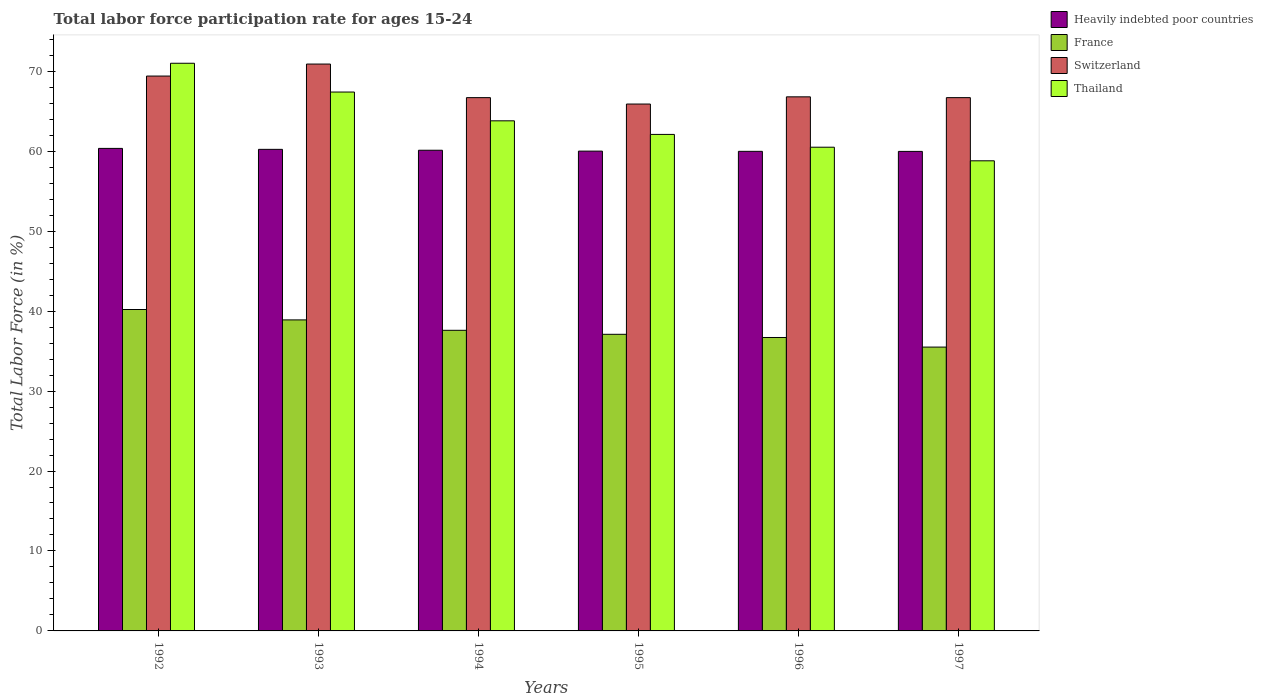How many different coloured bars are there?
Offer a very short reply. 4. How many groups of bars are there?
Offer a very short reply. 6. Are the number of bars per tick equal to the number of legend labels?
Make the answer very short. Yes. Are the number of bars on each tick of the X-axis equal?
Your answer should be compact. Yes. How many bars are there on the 6th tick from the right?
Give a very brief answer. 4. In how many cases, is the number of bars for a given year not equal to the number of legend labels?
Provide a short and direct response. 0. What is the labor force participation rate in Switzerland in 1992?
Your answer should be very brief. 69.4. Across all years, what is the maximum labor force participation rate in France?
Your response must be concise. 40.2. Across all years, what is the minimum labor force participation rate in Thailand?
Your response must be concise. 58.8. In which year was the labor force participation rate in France maximum?
Make the answer very short. 1992. What is the total labor force participation rate in Switzerland in the graph?
Keep it short and to the point. 406.4. What is the difference between the labor force participation rate in Switzerland in 1996 and that in 1997?
Your answer should be very brief. 0.1. What is the difference between the labor force participation rate in Switzerland in 1997 and the labor force participation rate in Heavily indebted poor countries in 1996?
Your answer should be very brief. 6.72. What is the average labor force participation rate in Thailand per year?
Keep it short and to the point. 63.93. In the year 1993, what is the difference between the labor force participation rate in Switzerland and labor force participation rate in France?
Your response must be concise. 32. What is the ratio of the labor force participation rate in Thailand in 1993 to that in 1995?
Offer a very short reply. 1.09. Is the difference between the labor force participation rate in Switzerland in 1992 and 1993 greater than the difference between the labor force participation rate in France in 1992 and 1993?
Give a very brief answer. No. What is the difference between the highest and the second highest labor force participation rate in Switzerland?
Make the answer very short. 1.5. What is the difference between the highest and the lowest labor force participation rate in France?
Give a very brief answer. 4.7. In how many years, is the labor force participation rate in Switzerland greater than the average labor force participation rate in Switzerland taken over all years?
Keep it short and to the point. 2. Is it the case that in every year, the sum of the labor force participation rate in Switzerland and labor force participation rate in Heavily indebted poor countries is greater than the sum of labor force participation rate in France and labor force participation rate in Thailand?
Your response must be concise. Yes. What does the 2nd bar from the left in 1992 represents?
Make the answer very short. France. What does the 4th bar from the right in 1995 represents?
Keep it short and to the point. Heavily indebted poor countries. Is it the case that in every year, the sum of the labor force participation rate in France and labor force participation rate in Switzerland is greater than the labor force participation rate in Heavily indebted poor countries?
Offer a terse response. Yes. How many years are there in the graph?
Keep it short and to the point. 6. Does the graph contain grids?
Offer a terse response. No. How many legend labels are there?
Offer a terse response. 4. How are the legend labels stacked?
Your answer should be very brief. Vertical. What is the title of the graph?
Provide a succinct answer. Total labor force participation rate for ages 15-24. What is the label or title of the X-axis?
Provide a short and direct response. Years. What is the Total Labor Force (in %) of Heavily indebted poor countries in 1992?
Offer a terse response. 60.35. What is the Total Labor Force (in %) of France in 1992?
Offer a terse response. 40.2. What is the Total Labor Force (in %) in Switzerland in 1992?
Provide a succinct answer. 69.4. What is the Total Labor Force (in %) of Thailand in 1992?
Your response must be concise. 71. What is the Total Labor Force (in %) of Heavily indebted poor countries in 1993?
Provide a short and direct response. 60.23. What is the Total Labor Force (in %) in France in 1993?
Your answer should be very brief. 38.9. What is the Total Labor Force (in %) of Switzerland in 1993?
Offer a terse response. 70.9. What is the Total Labor Force (in %) of Thailand in 1993?
Provide a short and direct response. 67.4. What is the Total Labor Force (in %) of Heavily indebted poor countries in 1994?
Keep it short and to the point. 60.12. What is the Total Labor Force (in %) of France in 1994?
Keep it short and to the point. 37.6. What is the Total Labor Force (in %) in Switzerland in 1994?
Provide a succinct answer. 66.7. What is the Total Labor Force (in %) in Thailand in 1994?
Your response must be concise. 63.8. What is the Total Labor Force (in %) of Heavily indebted poor countries in 1995?
Offer a very short reply. 60.01. What is the Total Labor Force (in %) in France in 1995?
Offer a very short reply. 37.1. What is the Total Labor Force (in %) in Switzerland in 1995?
Your answer should be compact. 65.9. What is the Total Labor Force (in %) in Thailand in 1995?
Make the answer very short. 62.1. What is the Total Labor Force (in %) in Heavily indebted poor countries in 1996?
Give a very brief answer. 59.98. What is the Total Labor Force (in %) in France in 1996?
Offer a terse response. 36.7. What is the Total Labor Force (in %) of Switzerland in 1996?
Your answer should be very brief. 66.8. What is the Total Labor Force (in %) of Thailand in 1996?
Provide a succinct answer. 60.5. What is the Total Labor Force (in %) of Heavily indebted poor countries in 1997?
Offer a very short reply. 59.98. What is the Total Labor Force (in %) of France in 1997?
Keep it short and to the point. 35.5. What is the Total Labor Force (in %) in Switzerland in 1997?
Provide a succinct answer. 66.7. What is the Total Labor Force (in %) of Thailand in 1997?
Make the answer very short. 58.8. Across all years, what is the maximum Total Labor Force (in %) in Heavily indebted poor countries?
Make the answer very short. 60.35. Across all years, what is the maximum Total Labor Force (in %) in France?
Provide a succinct answer. 40.2. Across all years, what is the maximum Total Labor Force (in %) in Switzerland?
Ensure brevity in your answer.  70.9. Across all years, what is the maximum Total Labor Force (in %) of Thailand?
Keep it short and to the point. 71. Across all years, what is the minimum Total Labor Force (in %) in Heavily indebted poor countries?
Make the answer very short. 59.98. Across all years, what is the minimum Total Labor Force (in %) in France?
Keep it short and to the point. 35.5. Across all years, what is the minimum Total Labor Force (in %) of Switzerland?
Ensure brevity in your answer.  65.9. Across all years, what is the minimum Total Labor Force (in %) of Thailand?
Offer a terse response. 58.8. What is the total Total Labor Force (in %) in Heavily indebted poor countries in the graph?
Your response must be concise. 360.67. What is the total Total Labor Force (in %) of France in the graph?
Provide a succinct answer. 226. What is the total Total Labor Force (in %) in Switzerland in the graph?
Give a very brief answer. 406.4. What is the total Total Labor Force (in %) of Thailand in the graph?
Your answer should be compact. 383.6. What is the difference between the Total Labor Force (in %) in Heavily indebted poor countries in 1992 and that in 1993?
Offer a terse response. 0.12. What is the difference between the Total Labor Force (in %) in Thailand in 1992 and that in 1993?
Your answer should be compact. 3.6. What is the difference between the Total Labor Force (in %) of Heavily indebted poor countries in 1992 and that in 1994?
Your answer should be very brief. 0.23. What is the difference between the Total Labor Force (in %) of France in 1992 and that in 1994?
Your response must be concise. 2.6. What is the difference between the Total Labor Force (in %) of Heavily indebted poor countries in 1992 and that in 1995?
Your answer should be compact. 0.34. What is the difference between the Total Labor Force (in %) in Heavily indebted poor countries in 1992 and that in 1996?
Your answer should be compact. 0.37. What is the difference between the Total Labor Force (in %) in Switzerland in 1992 and that in 1996?
Provide a succinct answer. 2.6. What is the difference between the Total Labor Force (in %) in Thailand in 1992 and that in 1996?
Offer a terse response. 10.5. What is the difference between the Total Labor Force (in %) in Heavily indebted poor countries in 1992 and that in 1997?
Provide a succinct answer. 0.38. What is the difference between the Total Labor Force (in %) in Switzerland in 1992 and that in 1997?
Provide a short and direct response. 2.7. What is the difference between the Total Labor Force (in %) of Thailand in 1992 and that in 1997?
Your answer should be compact. 12.2. What is the difference between the Total Labor Force (in %) of Heavily indebted poor countries in 1993 and that in 1994?
Ensure brevity in your answer.  0.11. What is the difference between the Total Labor Force (in %) in Switzerland in 1993 and that in 1994?
Offer a terse response. 4.2. What is the difference between the Total Labor Force (in %) in Thailand in 1993 and that in 1994?
Offer a very short reply. 3.6. What is the difference between the Total Labor Force (in %) of Heavily indebted poor countries in 1993 and that in 1995?
Make the answer very short. 0.22. What is the difference between the Total Labor Force (in %) of Heavily indebted poor countries in 1993 and that in 1996?
Your answer should be very brief. 0.25. What is the difference between the Total Labor Force (in %) in France in 1993 and that in 1996?
Your answer should be compact. 2.2. What is the difference between the Total Labor Force (in %) in Thailand in 1993 and that in 1996?
Provide a succinct answer. 6.9. What is the difference between the Total Labor Force (in %) in Heavily indebted poor countries in 1993 and that in 1997?
Keep it short and to the point. 0.26. What is the difference between the Total Labor Force (in %) of Heavily indebted poor countries in 1994 and that in 1995?
Make the answer very short. 0.11. What is the difference between the Total Labor Force (in %) in France in 1994 and that in 1995?
Ensure brevity in your answer.  0.5. What is the difference between the Total Labor Force (in %) in Switzerland in 1994 and that in 1995?
Give a very brief answer. 0.8. What is the difference between the Total Labor Force (in %) of Thailand in 1994 and that in 1995?
Offer a terse response. 1.7. What is the difference between the Total Labor Force (in %) in Heavily indebted poor countries in 1994 and that in 1996?
Offer a terse response. 0.14. What is the difference between the Total Labor Force (in %) of France in 1994 and that in 1996?
Make the answer very short. 0.9. What is the difference between the Total Labor Force (in %) of Thailand in 1994 and that in 1996?
Offer a very short reply. 3.3. What is the difference between the Total Labor Force (in %) in Heavily indebted poor countries in 1994 and that in 1997?
Make the answer very short. 0.15. What is the difference between the Total Labor Force (in %) in Switzerland in 1994 and that in 1997?
Keep it short and to the point. 0. What is the difference between the Total Labor Force (in %) of Heavily indebted poor countries in 1995 and that in 1996?
Your response must be concise. 0.03. What is the difference between the Total Labor Force (in %) of France in 1995 and that in 1996?
Provide a succinct answer. 0.4. What is the difference between the Total Labor Force (in %) in Heavily indebted poor countries in 1995 and that in 1997?
Your answer should be very brief. 0.03. What is the difference between the Total Labor Force (in %) in Heavily indebted poor countries in 1996 and that in 1997?
Keep it short and to the point. 0.01. What is the difference between the Total Labor Force (in %) of Thailand in 1996 and that in 1997?
Make the answer very short. 1.7. What is the difference between the Total Labor Force (in %) in Heavily indebted poor countries in 1992 and the Total Labor Force (in %) in France in 1993?
Your answer should be very brief. 21.45. What is the difference between the Total Labor Force (in %) of Heavily indebted poor countries in 1992 and the Total Labor Force (in %) of Switzerland in 1993?
Your answer should be very brief. -10.55. What is the difference between the Total Labor Force (in %) in Heavily indebted poor countries in 1992 and the Total Labor Force (in %) in Thailand in 1993?
Your answer should be compact. -7.05. What is the difference between the Total Labor Force (in %) in France in 1992 and the Total Labor Force (in %) in Switzerland in 1993?
Give a very brief answer. -30.7. What is the difference between the Total Labor Force (in %) in France in 1992 and the Total Labor Force (in %) in Thailand in 1993?
Provide a short and direct response. -27.2. What is the difference between the Total Labor Force (in %) in Heavily indebted poor countries in 1992 and the Total Labor Force (in %) in France in 1994?
Your answer should be compact. 22.75. What is the difference between the Total Labor Force (in %) of Heavily indebted poor countries in 1992 and the Total Labor Force (in %) of Switzerland in 1994?
Ensure brevity in your answer.  -6.35. What is the difference between the Total Labor Force (in %) of Heavily indebted poor countries in 1992 and the Total Labor Force (in %) of Thailand in 1994?
Provide a succinct answer. -3.45. What is the difference between the Total Labor Force (in %) in France in 1992 and the Total Labor Force (in %) in Switzerland in 1994?
Your answer should be very brief. -26.5. What is the difference between the Total Labor Force (in %) in France in 1992 and the Total Labor Force (in %) in Thailand in 1994?
Ensure brevity in your answer.  -23.6. What is the difference between the Total Labor Force (in %) of Heavily indebted poor countries in 1992 and the Total Labor Force (in %) of France in 1995?
Keep it short and to the point. 23.25. What is the difference between the Total Labor Force (in %) in Heavily indebted poor countries in 1992 and the Total Labor Force (in %) in Switzerland in 1995?
Provide a short and direct response. -5.55. What is the difference between the Total Labor Force (in %) of Heavily indebted poor countries in 1992 and the Total Labor Force (in %) of Thailand in 1995?
Your answer should be compact. -1.75. What is the difference between the Total Labor Force (in %) in France in 1992 and the Total Labor Force (in %) in Switzerland in 1995?
Provide a succinct answer. -25.7. What is the difference between the Total Labor Force (in %) of France in 1992 and the Total Labor Force (in %) of Thailand in 1995?
Your response must be concise. -21.9. What is the difference between the Total Labor Force (in %) in Heavily indebted poor countries in 1992 and the Total Labor Force (in %) in France in 1996?
Offer a very short reply. 23.65. What is the difference between the Total Labor Force (in %) of Heavily indebted poor countries in 1992 and the Total Labor Force (in %) of Switzerland in 1996?
Your answer should be compact. -6.45. What is the difference between the Total Labor Force (in %) of Heavily indebted poor countries in 1992 and the Total Labor Force (in %) of Thailand in 1996?
Offer a terse response. -0.15. What is the difference between the Total Labor Force (in %) of France in 1992 and the Total Labor Force (in %) of Switzerland in 1996?
Your response must be concise. -26.6. What is the difference between the Total Labor Force (in %) of France in 1992 and the Total Labor Force (in %) of Thailand in 1996?
Your response must be concise. -20.3. What is the difference between the Total Labor Force (in %) of Heavily indebted poor countries in 1992 and the Total Labor Force (in %) of France in 1997?
Provide a short and direct response. 24.85. What is the difference between the Total Labor Force (in %) in Heavily indebted poor countries in 1992 and the Total Labor Force (in %) in Switzerland in 1997?
Keep it short and to the point. -6.35. What is the difference between the Total Labor Force (in %) in Heavily indebted poor countries in 1992 and the Total Labor Force (in %) in Thailand in 1997?
Offer a very short reply. 1.55. What is the difference between the Total Labor Force (in %) in France in 1992 and the Total Labor Force (in %) in Switzerland in 1997?
Make the answer very short. -26.5. What is the difference between the Total Labor Force (in %) in France in 1992 and the Total Labor Force (in %) in Thailand in 1997?
Make the answer very short. -18.6. What is the difference between the Total Labor Force (in %) of Heavily indebted poor countries in 1993 and the Total Labor Force (in %) of France in 1994?
Provide a succinct answer. 22.63. What is the difference between the Total Labor Force (in %) of Heavily indebted poor countries in 1993 and the Total Labor Force (in %) of Switzerland in 1994?
Your answer should be very brief. -6.47. What is the difference between the Total Labor Force (in %) of Heavily indebted poor countries in 1993 and the Total Labor Force (in %) of Thailand in 1994?
Ensure brevity in your answer.  -3.57. What is the difference between the Total Labor Force (in %) of France in 1993 and the Total Labor Force (in %) of Switzerland in 1994?
Your answer should be very brief. -27.8. What is the difference between the Total Labor Force (in %) in France in 1993 and the Total Labor Force (in %) in Thailand in 1994?
Ensure brevity in your answer.  -24.9. What is the difference between the Total Labor Force (in %) in Heavily indebted poor countries in 1993 and the Total Labor Force (in %) in France in 1995?
Give a very brief answer. 23.13. What is the difference between the Total Labor Force (in %) in Heavily indebted poor countries in 1993 and the Total Labor Force (in %) in Switzerland in 1995?
Make the answer very short. -5.67. What is the difference between the Total Labor Force (in %) of Heavily indebted poor countries in 1993 and the Total Labor Force (in %) of Thailand in 1995?
Give a very brief answer. -1.87. What is the difference between the Total Labor Force (in %) in France in 1993 and the Total Labor Force (in %) in Switzerland in 1995?
Keep it short and to the point. -27. What is the difference between the Total Labor Force (in %) of France in 1993 and the Total Labor Force (in %) of Thailand in 1995?
Offer a very short reply. -23.2. What is the difference between the Total Labor Force (in %) of Heavily indebted poor countries in 1993 and the Total Labor Force (in %) of France in 1996?
Give a very brief answer. 23.53. What is the difference between the Total Labor Force (in %) in Heavily indebted poor countries in 1993 and the Total Labor Force (in %) in Switzerland in 1996?
Give a very brief answer. -6.57. What is the difference between the Total Labor Force (in %) in Heavily indebted poor countries in 1993 and the Total Labor Force (in %) in Thailand in 1996?
Offer a very short reply. -0.27. What is the difference between the Total Labor Force (in %) of France in 1993 and the Total Labor Force (in %) of Switzerland in 1996?
Offer a very short reply. -27.9. What is the difference between the Total Labor Force (in %) in France in 1993 and the Total Labor Force (in %) in Thailand in 1996?
Offer a terse response. -21.6. What is the difference between the Total Labor Force (in %) of Switzerland in 1993 and the Total Labor Force (in %) of Thailand in 1996?
Ensure brevity in your answer.  10.4. What is the difference between the Total Labor Force (in %) in Heavily indebted poor countries in 1993 and the Total Labor Force (in %) in France in 1997?
Ensure brevity in your answer.  24.73. What is the difference between the Total Labor Force (in %) in Heavily indebted poor countries in 1993 and the Total Labor Force (in %) in Switzerland in 1997?
Offer a terse response. -6.47. What is the difference between the Total Labor Force (in %) of Heavily indebted poor countries in 1993 and the Total Labor Force (in %) of Thailand in 1997?
Your answer should be very brief. 1.43. What is the difference between the Total Labor Force (in %) in France in 1993 and the Total Labor Force (in %) in Switzerland in 1997?
Ensure brevity in your answer.  -27.8. What is the difference between the Total Labor Force (in %) of France in 1993 and the Total Labor Force (in %) of Thailand in 1997?
Offer a terse response. -19.9. What is the difference between the Total Labor Force (in %) in Heavily indebted poor countries in 1994 and the Total Labor Force (in %) in France in 1995?
Keep it short and to the point. 23.02. What is the difference between the Total Labor Force (in %) in Heavily indebted poor countries in 1994 and the Total Labor Force (in %) in Switzerland in 1995?
Make the answer very short. -5.78. What is the difference between the Total Labor Force (in %) of Heavily indebted poor countries in 1994 and the Total Labor Force (in %) of Thailand in 1995?
Offer a very short reply. -1.98. What is the difference between the Total Labor Force (in %) of France in 1994 and the Total Labor Force (in %) of Switzerland in 1995?
Ensure brevity in your answer.  -28.3. What is the difference between the Total Labor Force (in %) of France in 1994 and the Total Labor Force (in %) of Thailand in 1995?
Your answer should be compact. -24.5. What is the difference between the Total Labor Force (in %) in Heavily indebted poor countries in 1994 and the Total Labor Force (in %) in France in 1996?
Offer a terse response. 23.42. What is the difference between the Total Labor Force (in %) in Heavily indebted poor countries in 1994 and the Total Labor Force (in %) in Switzerland in 1996?
Give a very brief answer. -6.68. What is the difference between the Total Labor Force (in %) in Heavily indebted poor countries in 1994 and the Total Labor Force (in %) in Thailand in 1996?
Give a very brief answer. -0.38. What is the difference between the Total Labor Force (in %) in France in 1994 and the Total Labor Force (in %) in Switzerland in 1996?
Your answer should be compact. -29.2. What is the difference between the Total Labor Force (in %) of France in 1994 and the Total Labor Force (in %) of Thailand in 1996?
Keep it short and to the point. -22.9. What is the difference between the Total Labor Force (in %) of Heavily indebted poor countries in 1994 and the Total Labor Force (in %) of France in 1997?
Provide a succinct answer. 24.62. What is the difference between the Total Labor Force (in %) in Heavily indebted poor countries in 1994 and the Total Labor Force (in %) in Switzerland in 1997?
Provide a short and direct response. -6.58. What is the difference between the Total Labor Force (in %) of Heavily indebted poor countries in 1994 and the Total Labor Force (in %) of Thailand in 1997?
Provide a short and direct response. 1.32. What is the difference between the Total Labor Force (in %) of France in 1994 and the Total Labor Force (in %) of Switzerland in 1997?
Offer a very short reply. -29.1. What is the difference between the Total Labor Force (in %) in France in 1994 and the Total Labor Force (in %) in Thailand in 1997?
Keep it short and to the point. -21.2. What is the difference between the Total Labor Force (in %) in Switzerland in 1994 and the Total Labor Force (in %) in Thailand in 1997?
Your response must be concise. 7.9. What is the difference between the Total Labor Force (in %) of Heavily indebted poor countries in 1995 and the Total Labor Force (in %) of France in 1996?
Provide a succinct answer. 23.31. What is the difference between the Total Labor Force (in %) of Heavily indebted poor countries in 1995 and the Total Labor Force (in %) of Switzerland in 1996?
Ensure brevity in your answer.  -6.79. What is the difference between the Total Labor Force (in %) in Heavily indebted poor countries in 1995 and the Total Labor Force (in %) in Thailand in 1996?
Your answer should be very brief. -0.49. What is the difference between the Total Labor Force (in %) in France in 1995 and the Total Labor Force (in %) in Switzerland in 1996?
Provide a short and direct response. -29.7. What is the difference between the Total Labor Force (in %) in France in 1995 and the Total Labor Force (in %) in Thailand in 1996?
Your response must be concise. -23.4. What is the difference between the Total Labor Force (in %) in Switzerland in 1995 and the Total Labor Force (in %) in Thailand in 1996?
Provide a succinct answer. 5.4. What is the difference between the Total Labor Force (in %) of Heavily indebted poor countries in 1995 and the Total Labor Force (in %) of France in 1997?
Your response must be concise. 24.51. What is the difference between the Total Labor Force (in %) of Heavily indebted poor countries in 1995 and the Total Labor Force (in %) of Switzerland in 1997?
Offer a very short reply. -6.69. What is the difference between the Total Labor Force (in %) in Heavily indebted poor countries in 1995 and the Total Labor Force (in %) in Thailand in 1997?
Your answer should be compact. 1.21. What is the difference between the Total Labor Force (in %) of France in 1995 and the Total Labor Force (in %) of Switzerland in 1997?
Offer a very short reply. -29.6. What is the difference between the Total Labor Force (in %) in France in 1995 and the Total Labor Force (in %) in Thailand in 1997?
Give a very brief answer. -21.7. What is the difference between the Total Labor Force (in %) in Heavily indebted poor countries in 1996 and the Total Labor Force (in %) in France in 1997?
Keep it short and to the point. 24.48. What is the difference between the Total Labor Force (in %) of Heavily indebted poor countries in 1996 and the Total Labor Force (in %) of Switzerland in 1997?
Offer a terse response. -6.72. What is the difference between the Total Labor Force (in %) of Heavily indebted poor countries in 1996 and the Total Labor Force (in %) of Thailand in 1997?
Your response must be concise. 1.18. What is the difference between the Total Labor Force (in %) of France in 1996 and the Total Labor Force (in %) of Thailand in 1997?
Your answer should be compact. -22.1. What is the difference between the Total Labor Force (in %) of Switzerland in 1996 and the Total Labor Force (in %) of Thailand in 1997?
Offer a terse response. 8. What is the average Total Labor Force (in %) of Heavily indebted poor countries per year?
Ensure brevity in your answer.  60.11. What is the average Total Labor Force (in %) of France per year?
Ensure brevity in your answer.  37.67. What is the average Total Labor Force (in %) of Switzerland per year?
Provide a short and direct response. 67.73. What is the average Total Labor Force (in %) in Thailand per year?
Make the answer very short. 63.93. In the year 1992, what is the difference between the Total Labor Force (in %) in Heavily indebted poor countries and Total Labor Force (in %) in France?
Give a very brief answer. 20.15. In the year 1992, what is the difference between the Total Labor Force (in %) of Heavily indebted poor countries and Total Labor Force (in %) of Switzerland?
Your answer should be compact. -9.05. In the year 1992, what is the difference between the Total Labor Force (in %) of Heavily indebted poor countries and Total Labor Force (in %) of Thailand?
Ensure brevity in your answer.  -10.65. In the year 1992, what is the difference between the Total Labor Force (in %) of France and Total Labor Force (in %) of Switzerland?
Make the answer very short. -29.2. In the year 1992, what is the difference between the Total Labor Force (in %) in France and Total Labor Force (in %) in Thailand?
Provide a short and direct response. -30.8. In the year 1992, what is the difference between the Total Labor Force (in %) in Switzerland and Total Labor Force (in %) in Thailand?
Your answer should be very brief. -1.6. In the year 1993, what is the difference between the Total Labor Force (in %) of Heavily indebted poor countries and Total Labor Force (in %) of France?
Offer a very short reply. 21.33. In the year 1993, what is the difference between the Total Labor Force (in %) in Heavily indebted poor countries and Total Labor Force (in %) in Switzerland?
Provide a succinct answer. -10.67. In the year 1993, what is the difference between the Total Labor Force (in %) of Heavily indebted poor countries and Total Labor Force (in %) of Thailand?
Ensure brevity in your answer.  -7.17. In the year 1993, what is the difference between the Total Labor Force (in %) in France and Total Labor Force (in %) in Switzerland?
Your answer should be compact. -32. In the year 1993, what is the difference between the Total Labor Force (in %) of France and Total Labor Force (in %) of Thailand?
Your answer should be compact. -28.5. In the year 1993, what is the difference between the Total Labor Force (in %) in Switzerland and Total Labor Force (in %) in Thailand?
Give a very brief answer. 3.5. In the year 1994, what is the difference between the Total Labor Force (in %) of Heavily indebted poor countries and Total Labor Force (in %) of France?
Make the answer very short. 22.52. In the year 1994, what is the difference between the Total Labor Force (in %) in Heavily indebted poor countries and Total Labor Force (in %) in Switzerland?
Your answer should be very brief. -6.58. In the year 1994, what is the difference between the Total Labor Force (in %) in Heavily indebted poor countries and Total Labor Force (in %) in Thailand?
Your response must be concise. -3.68. In the year 1994, what is the difference between the Total Labor Force (in %) of France and Total Labor Force (in %) of Switzerland?
Your answer should be compact. -29.1. In the year 1994, what is the difference between the Total Labor Force (in %) of France and Total Labor Force (in %) of Thailand?
Ensure brevity in your answer.  -26.2. In the year 1994, what is the difference between the Total Labor Force (in %) in Switzerland and Total Labor Force (in %) in Thailand?
Offer a terse response. 2.9. In the year 1995, what is the difference between the Total Labor Force (in %) in Heavily indebted poor countries and Total Labor Force (in %) in France?
Your response must be concise. 22.91. In the year 1995, what is the difference between the Total Labor Force (in %) of Heavily indebted poor countries and Total Labor Force (in %) of Switzerland?
Make the answer very short. -5.89. In the year 1995, what is the difference between the Total Labor Force (in %) of Heavily indebted poor countries and Total Labor Force (in %) of Thailand?
Your response must be concise. -2.09. In the year 1995, what is the difference between the Total Labor Force (in %) of France and Total Labor Force (in %) of Switzerland?
Make the answer very short. -28.8. In the year 1995, what is the difference between the Total Labor Force (in %) in France and Total Labor Force (in %) in Thailand?
Your answer should be very brief. -25. In the year 1995, what is the difference between the Total Labor Force (in %) in Switzerland and Total Labor Force (in %) in Thailand?
Keep it short and to the point. 3.8. In the year 1996, what is the difference between the Total Labor Force (in %) in Heavily indebted poor countries and Total Labor Force (in %) in France?
Your response must be concise. 23.28. In the year 1996, what is the difference between the Total Labor Force (in %) in Heavily indebted poor countries and Total Labor Force (in %) in Switzerland?
Provide a succinct answer. -6.82. In the year 1996, what is the difference between the Total Labor Force (in %) in Heavily indebted poor countries and Total Labor Force (in %) in Thailand?
Your response must be concise. -0.52. In the year 1996, what is the difference between the Total Labor Force (in %) of France and Total Labor Force (in %) of Switzerland?
Ensure brevity in your answer.  -30.1. In the year 1996, what is the difference between the Total Labor Force (in %) in France and Total Labor Force (in %) in Thailand?
Your response must be concise. -23.8. In the year 1997, what is the difference between the Total Labor Force (in %) in Heavily indebted poor countries and Total Labor Force (in %) in France?
Give a very brief answer. 24.48. In the year 1997, what is the difference between the Total Labor Force (in %) of Heavily indebted poor countries and Total Labor Force (in %) of Switzerland?
Provide a short and direct response. -6.72. In the year 1997, what is the difference between the Total Labor Force (in %) of Heavily indebted poor countries and Total Labor Force (in %) of Thailand?
Your answer should be very brief. 1.18. In the year 1997, what is the difference between the Total Labor Force (in %) in France and Total Labor Force (in %) in Switzerland?
Your response must be concise. -31.2. In the year 1997, what is the difference between the Total Labor Force (in %) in France and Total Labor Force (in %) in Thailand?
Offer a very short reply. -23.3. What is the ratio of the Total Labor Force (in %) in Heavily indebted poor countries in 1992 to that in 1993?
Offer a terse response. 1. What is the ratio of the Total Labor Force (in %) of France in 1992 to that in 1993?
Your answer should be very brief. 1.03. What is the ratio of the Total Labor Force (in %) of Switzerland in 1992 to that in 1993?
Offer a very short reply. 0.98. What is the ratio of the Total Labor Force (in %) of Thailand in 1992 to that in 1993?
Make the answer very short. 1.05. What is the ratio of the Total Labor Force (in %) of France in 1992 to that in 1994?
Your answer should be compact. 1.07. What is the ratio of the Total Labor Force (in %) of Switzerland in 1992 to that in 1994?
Give a very brief answer. 1.04. What is the ratio of the Total Labor Force (in %) in Thailand in 1992 to that in 1994?
Keep it short and to the point. 1.11. What is the ratio of the Total Labor Force (in %) in France in 1992 to that in 1995?
Ensure brevity in your answer.  1.08. What is the ratio of the Total Labor Force (in %) in Switzerland in 1992 to that in 1995?
Your answer should be very brief. 1.05. What is the ratio of the Total Labor Force (in %) in Thailand in 1992 to that in 1995?
Ensure brevity in your answer.  1.14. What is the ratio of the Total Labor Force (in %) in Heavily indebted poor countries in 1992 to that in 1996?
Give a very brief answer. 1.01. What is the ratio of the Total Labor Force (in %) of France in 1992 to that in 1996?
Give a very brief answer. 1.1. What is the ratio of the Total Labor Force (in %) in Switzerland in 1992 to that in 1996?
Offer a very short reply. 1.04. What is the ratio of the Total Labor Force (in %) of Thailand in 1992 to that in 1996?
Provide a short and direct response. 1.17. What is the ratio of the Total Labor Force (in %) of Heavily indebted poor countries in 1992 to that in 1997?
Your response must be concise. 1.01. What is the ratio of the Total Labor Force (in %) of France in 1992 to that in 1997?
Offer a very short reply. 1.13. What is the ratio of the Total Labor Force (in %) of Switzerland in 1992 to that in 1997?
Give a very brief answer. 1.04. What is the ratio of the Total Labor Force (in %) of Thailand in 1992 to that in 1997?
Give a very brief answer. 1.21. What is the ratio of the Total Labor Force (in %) of France in 1993 to that in 1994?
Make the answer very short. 1.03. What is the ratio of the Total Labor Force (in %) of Switzerland in 1993 to that in 1994?
Offer a very short reply. 1.06. What is the ratio of the Total Labor Force (in %) in Thailand in 1993 to that in 1994?
Provide a succinct answer. 1.06. What is the ratio of the Total Labor Force (in %) in France in 1993 to that in 1995?
Give a very brief answer. 1.05. What is the ratio of the Total Labor Force (in %) in Switzerland in 1993 to that in 1995?
Offer a terse response. 1.08. What is the ratio of the Total Labor Force (in %) in Thailand in 1993 to that in 1995?
Ensure brevity in your answer.  1.09. What is the ratio of the Total Labor Force (in %) in France in 1993 to that in 1996?
Your response must be concise. 1.06. What is the ratio of the Total Labor Force (in %) in Switzerland in 1993 to that in 1996?
Your response must be concise. 1.06. What is the ratio of the Total Labor Force (in %) of Thailand in 1993 to that in 1996?
Ensure brevity in your answer.  1.11. What is the ratio of the Total Labor Force (in %) in France in 1993 to that in 1997?
Ensure brevity in your answer.  1.1. What is the ratio of the Total Labor Force (in %) of Switzerland in 1993 to that in 1997?
Your answer should be compact. 1.06. What is the ratio of the Total Labor Force (in %) in Thailand in 1993 to that in 1997?
Your response must be concise. 1.15. What is the ratio of the Total Labor Force (in %) of Heavily indebted poor countries in 1994 to that in 1995?
Keep it short and to the point. 1. What is the ratio of the Total Labor Force (in %) in France in 1994 to that in 1995?
Offer a very short reply. 1.01. What is the ratio of the Total Labor Force (in %) in Switzerland in 1994 to that in 1995?
Ensure brevity in your answer.  1.01. What is the ratio of the Total Labor Force (in %) in Thailand in 1994 to that in 1995?
Your response must be concise. 1.03. What is the ratio of the Total Labor Force (in %) of France in 1994 to that in 1996?
Make the answer very short. 1.02. What is the ratio of the Total Labor Force (in %) in Thailand in 1994 to that in 1996?
Provide a short and direct response. 1.05. What is the ratio of the Total Labor Force (in %) of Heavily indebted poor countries in 1994 to that in 1997?
Make the answer very short. 1. What is the ratio of the Total Labor Force (in %) of France in 1994 to that in 1997?
Ensure brevity in your answer.  1.06. What is the ratio of the Total Labor Force (in %) in Switzerland in 1994 to that in 1997?
Make the answer very short. 1. What is the ratio of the Total Labor Force (in %) of Thailand in 1994 to that in 1997?
Make the answer very short. 1.08. What is the ratio of the Total Labor Force (in %) of France in 1995 to that in 1996?
Ensure brevity in your answer.  1.01. What is the ratio of the Total Labor Force (in %) of Switzerland in 1995 to that in 1996?
Provide a succinct answer. 0.99. What is the ratio of the Total Labor Force (in %) in Thailand in 1995 to that in 1996?
Keep it short and to the point. 1.03. What is the ratio of the Total Labor Force (in %) of Heavily indebted poor countries in 1995 to that in 1997?
Make the answer very short. 1. What is the ratio of the Total Labor Force (in %) of France in 1995 to that in 1997?
Make the answer very short. 1.05. What is the ratio of the Total Labor Force (in %) of Switzerland in 1995 to that in 1997?
Provide a succinct answer. 0.99. What is the ratio of the Total Labor Force (in %) of Thailand in 1995 to that in 1997?
Make the answer very short. 1.06. What is the ratio of the Total Labor Force (in %) of France in 1996 to that in 1997?
Offer a very short reply. 1.03. What is the ratio of the Total Labor Force (in %) of Thailand in 1996 to that in 1997?
Offer a terse response. 1.03. What is the difference between the highest and the second highest Total Labor Force (in %) in Heavily indebted poor countries?
Ensure brevity in your answer.  0.12. What is the difference between the highest and the second highest Total Labor Force (in %) in France?
Your answer should be compact. 1.3. What is the difference between the highest and the lowest Total Labor Force (in %) in France?
Provide a succinct answer. 4.7. What is the difference between the highest and the lowest Total Labor Force (in %) in Thailand?
Provide a short and direct response. 12.2. 